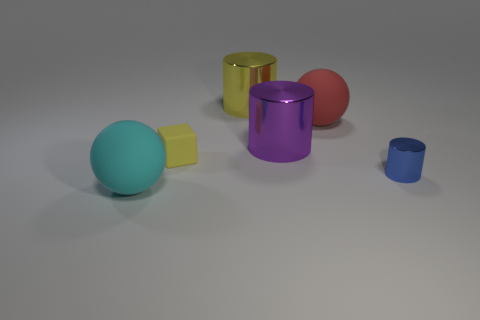Add 3 big red objects. How many objects exist? 9 Subtract all balls. How many objects are left? 4 Add 6 small yellow rubber things. How many small yellow rubber things exist? 7 Subtract 0 gray cylinders. How many objects are left? 6 Subtract all small yellow matte cylinders. Subtract all yellow things. How many objects are left? 4 Add 5 small blocks. How many small blocks are left? 6 